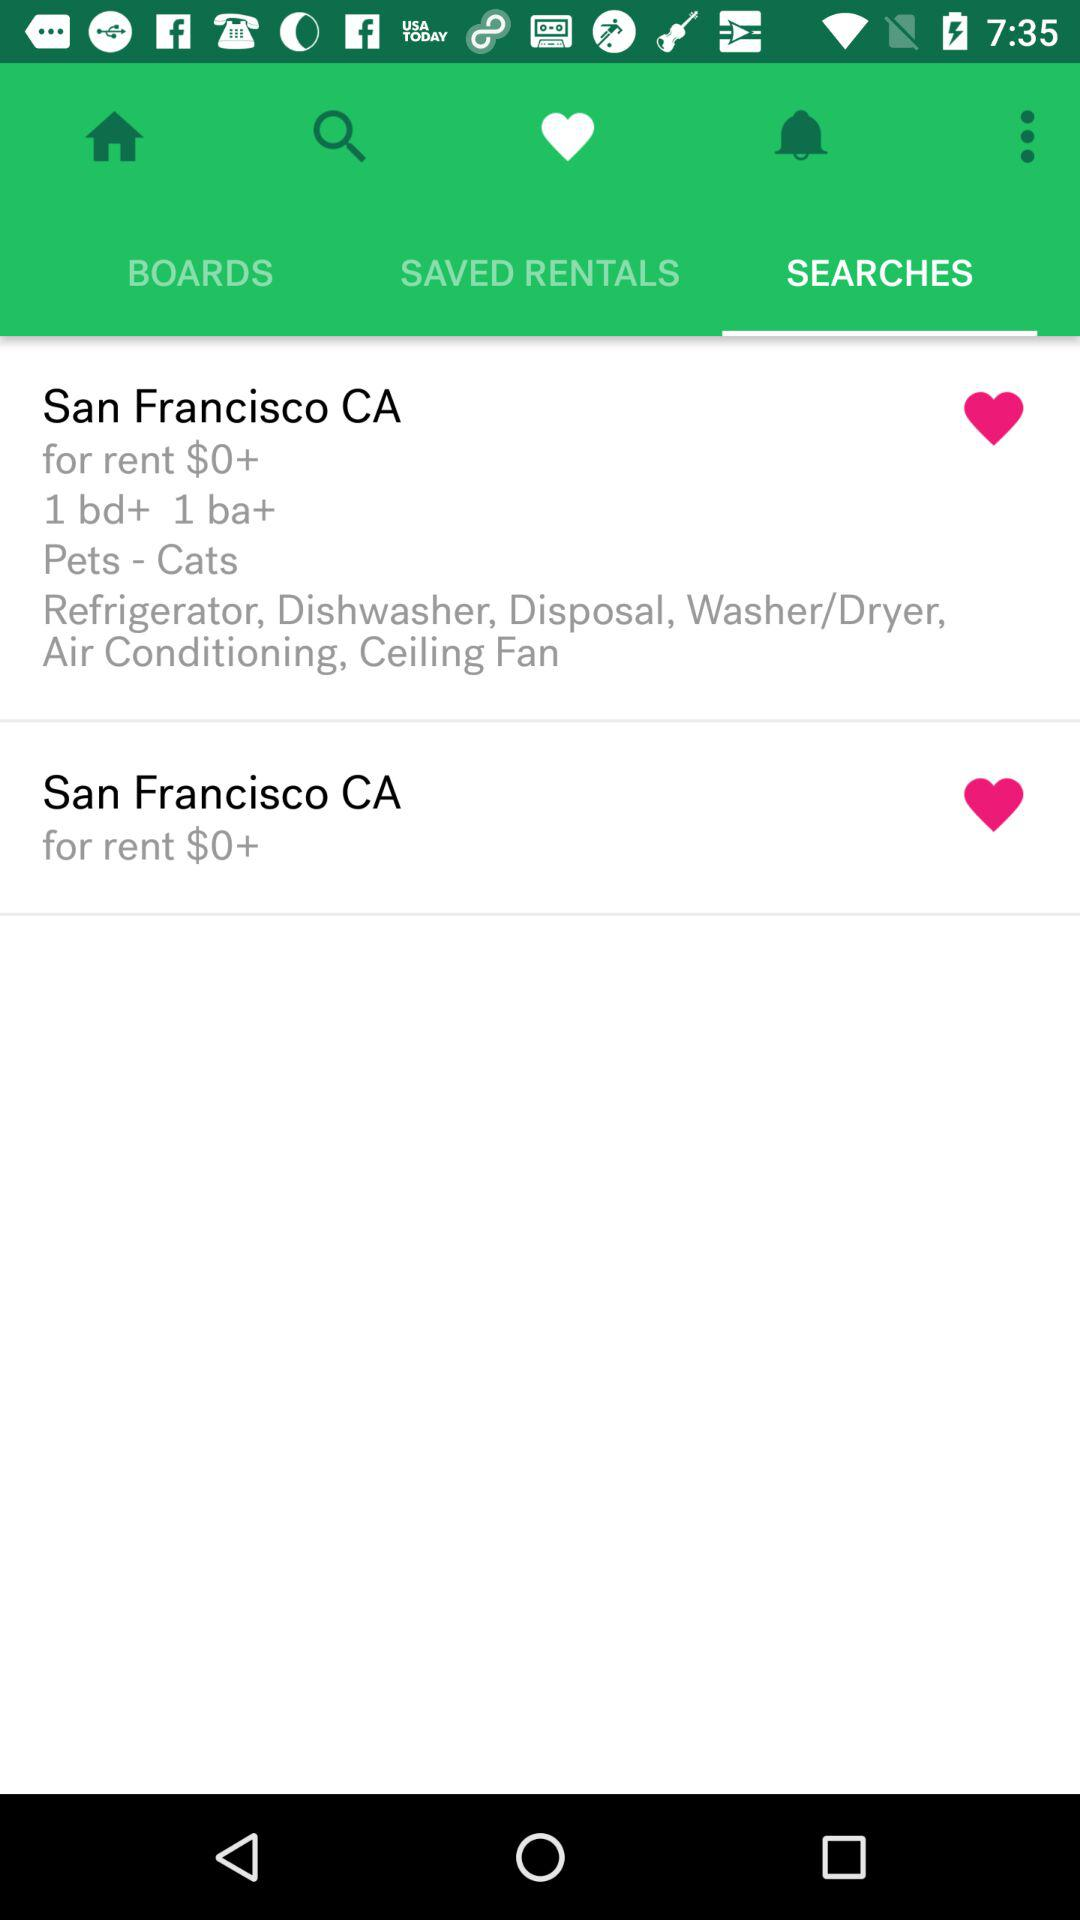What is the mentioned pet? The mentioned pets are cats. 